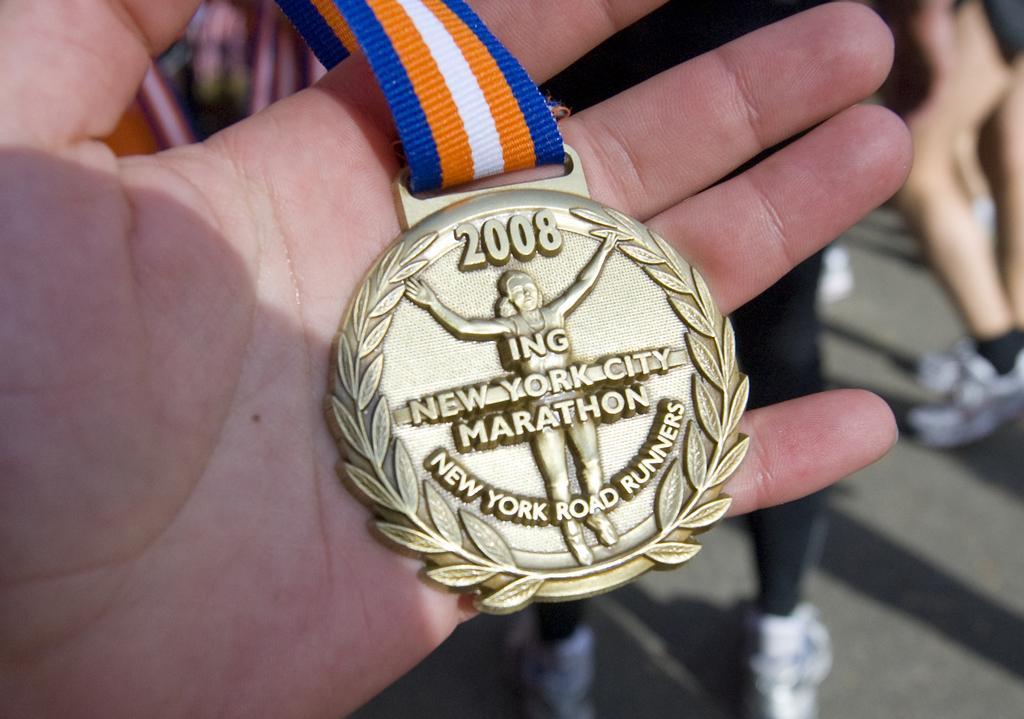Please provide a concise description of this image. In this picture I can see there is a person holding a medal and it has a blue, orange and white tag. In the backdrop there are few people standing. 